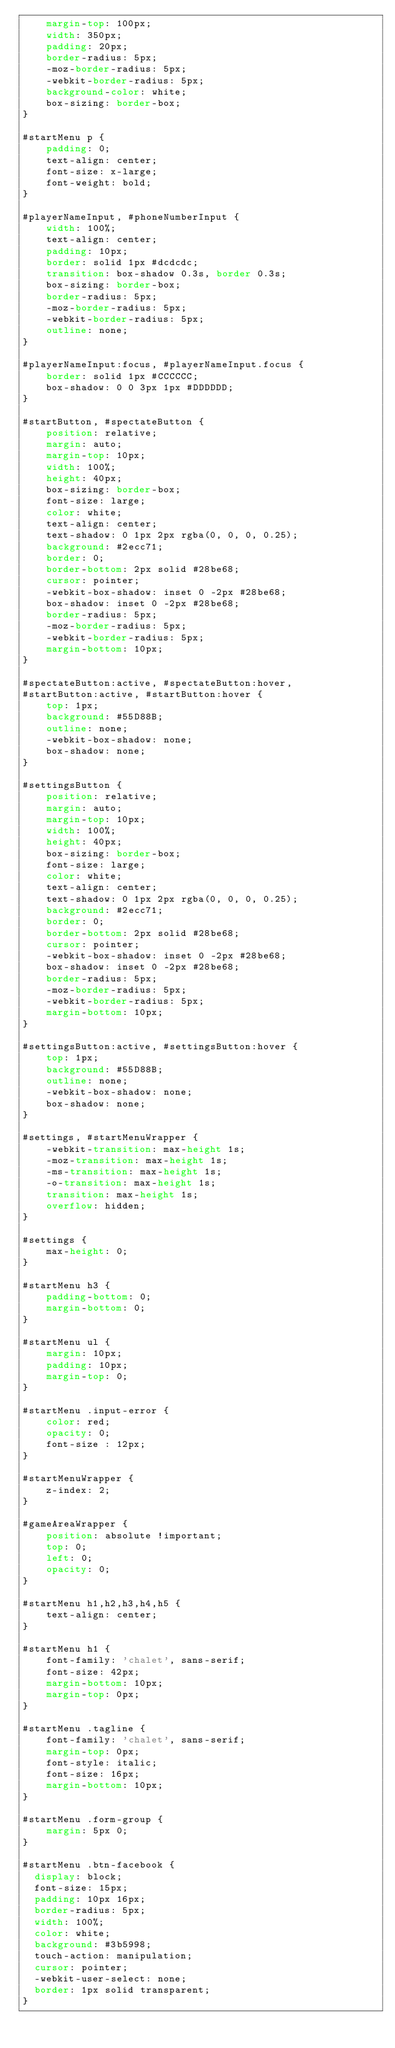Convert code to text. <code><loc_0><loc_0><loc_500><loc_500><_CSS_>    margin-top: 100px;
    width: 350px;
    padding: 20px;
    border-radius: 5px;
    -moz-border-radius: 5px;
    -webkit-border-radius: 5px;
    background-color: white;
    box-sizing: border-box;
}

#startMenu p {
    padding: 0;
    text-align: center;
    font-size: x-large;
    font-weight: bold;
}

#playerNameInput, #phoneNumberInput {
    width: 100%;
    text-align: center;
    padding: 10px;
    border: solid 1px #dcdcdc;
    transition: box-shadow 0.3s, border 0.3s;
    box-sizing: border-box;
    border-radius: 5px;
    -moz-border-radius: 5px;
    -webkit-border-radius: 5px;
    outline: none;
}

#playerNameInput:focus, #playerNameInput.focus {
    border: solid 1px #CCCCCC;
    box-shadow: 0 0 3px 1px #DDDDDD;
}

#startButton, #spectateButton {
    position: relative;
    margin: auto;
    margin-top: 10px;
    width: 100%;
    height: 40px;
    box-sizing: border-box;
    font-size: large;
    color: white;
    text-align: center;
    text-shadow: 0 1px 2px rgba(0, 0, 0, 0.25);
    background: #2ecc71;
    border: 0;
    border-bottom: 2px solid #28be68;
    cursor: pointer;
    -webkit-box-shadow: inset 0 -2px #28be68;
    box-shadow: inset 0 -2px #28be68;
    border-radius: 5px;
    -moz-border-radius: 5px;
    -webkit-border-radius: 5px;
    margin-bottom: 10px;
}

#spectateButton:active, #spectateButton:hover,
#startButton:active, #startButton:hover {
    top: 1px;
    background: #55D88B;
    outline: none;
    -webkit-box-shadow: none;
    box-shadow: none;
}

#settingsButton {
    position: relative;
    margin: auto;
    margin-top: 10px;
    width: 100%;
    height: 40px;
    box-sizing: border-box;
    font-size: large;
    color: white;
    text-align: center;
    text-shadow: 0 1px 2px rgba(0, 0, 0, 0.25);
    background: #2ecc71;
    border: 0;
    border-bottom: 2px solid #28be68;
    cursor: pointer;
    -webkit-box-shadow: inset 0 -2px #28be68;
    box-shadow: inset 0 -2px #28be68;
    border-radius: 5px;
    -moz-border-radius: 5px;
    -webkit-border-radius: 5px;
    margin-bottom: 10px;
}

#settingsButton:active, #settingsButton:hover {
    top: 1px;
    background: #55D88B;
    outline: none;
    -webkit-box-shadow: none;
    box-shadow: none;
}

#settings, #startMenuWrapper {
    -webkit-transition: max-height 1s;
    -moz-transition: max-height 1s;
    -ms-transition: max-height 1s;
    -o-transition: max-height 1s;
    transition: max-height 1s;
    overflow: hidden;
}

#settings {
    max-height: 0;
}

#startMenu h3 {
    padding-bottom: 0;
    margin-bottom: 0;
}

#startMenu ul {
    margin: 10px;
    padding: 10px;
    margin-top: 0;
}

#startMenu .input-error {
    color: red;
    opacity: 0;
    font-size : 12px;
}

#startMenuWrapper {
    z-index: 2;
}

#gameAreaWrapper {
    position: absolute !important;
    top: 0;
    left: 0;
    opacity: 0;
}

#startMenu h1,h2,h3,h4,h5 {
    text-align: center;
}

#startMenu h1 {
    font-family: 'chalet', sans-serif;
    font-size: 42px;
    margin-bottom: 10px;
    margin-top: 0px;
}

#startMenu .tagline {
    font-family: 'chalet', sans-serif;
    margin-top: 0px;
    font-style: italic;
    font-size: 16px;
    margin-bottom: 10px;
}

#startMenu .form-group {
    margin: 5px 0;
}

#startMenu .btn-facebook {
  display: block;
  font-size: 15px;
  padding: 10px 16px;
  border-radius: 5px;
  width: 100%;
  color: white;
  background: #3b5998;
  touch-action: manipulation;
  cursor: pointer;
  -webkit-user-select: none;
  border: 1px solid transparent;
}
</code> 